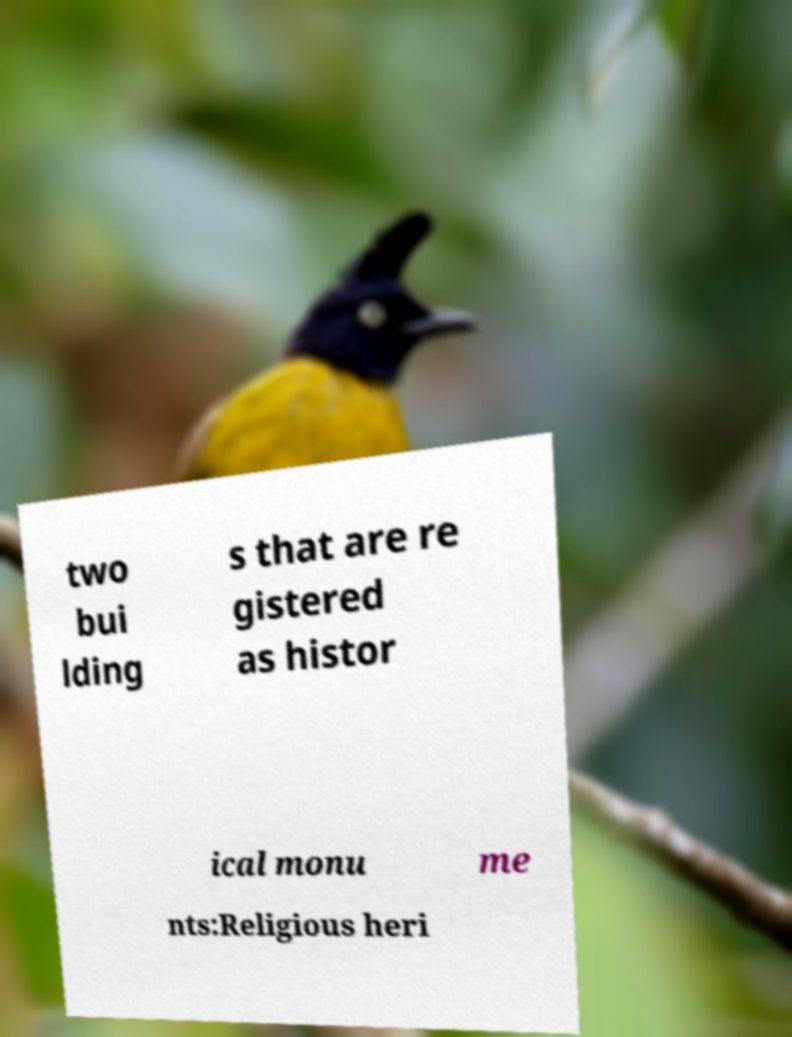Please read and relay the text visible in this image. What does it say? two bui lding s that are re gistered as histor ical monu me nts:Religious heri 